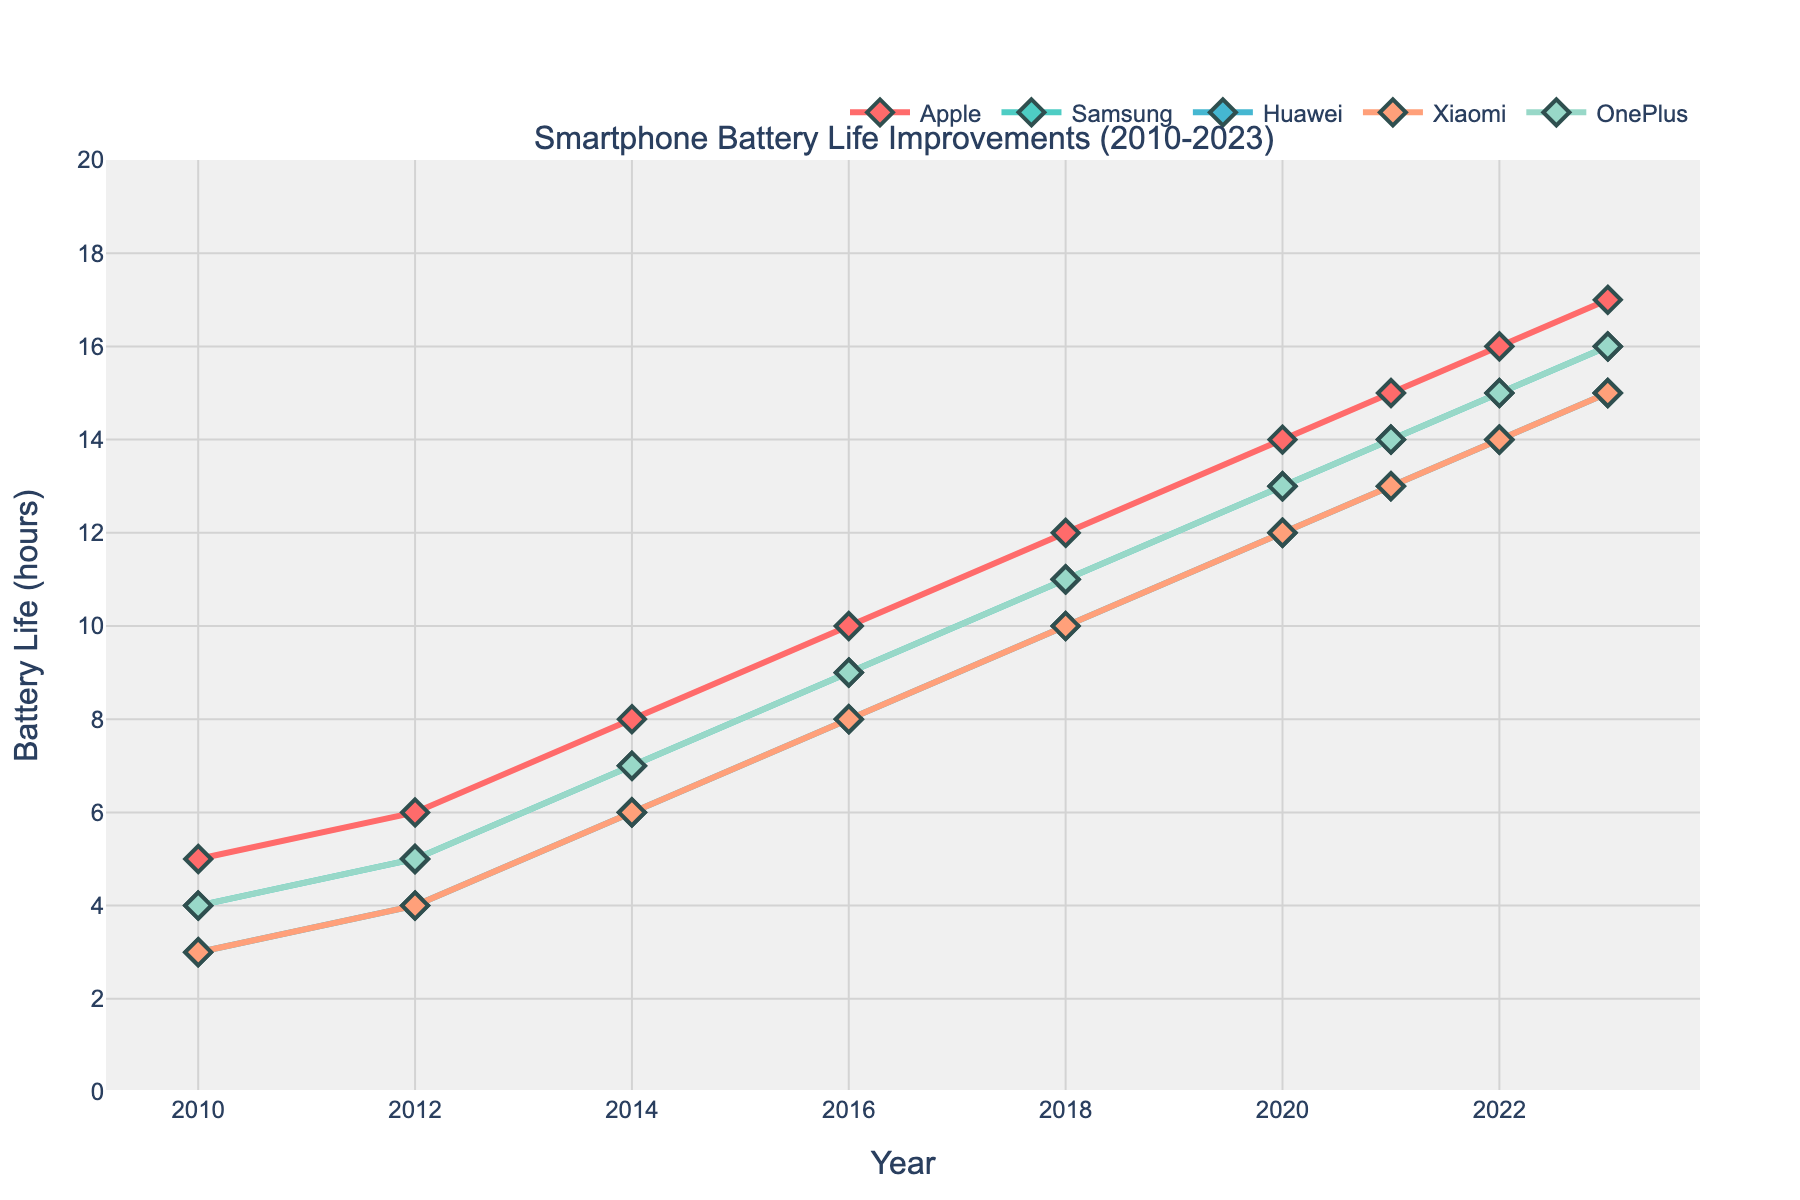What is the highest battery life recorded by Apple in the given period? To find the highest battery life reported by Apple, look at the line for Apple (colored in red) and find the maximum y-value from 2010 to 2023. The highest value is 17 hours in 2023.
Answer: 17 hours Between which years did Samsung see the greatest increase in battery life? To determine the period of greatest increase in battery life for Samsung, compare the vertical distances (change in y-values) between consecutive years. The largest increase is evident between 2010 and 2012, where the battery life went from 4 to 5 hours.
Answer: 2010-2012 At what year do all manufacturers first surpass 10 hours of battery life? Look at each manufacturer's line and determine the first year all surpass the 10-hour mark. In 2018, every manufacturer shows a battery life greater than 10 hours.
Answer: 2018 Which manufacturer had the slowest growth in battery life from 2010 to 2023? Calculate the increase in battery life for each manufacturer from 2010 to 2023. Apple increased from 5 to 17 hours, Samsung from 4 to 16 hours, Huawei from 3 to 15 hours, Xiaomi from 3 to 15 hours, and OnePlus from 4 to 16 hours. Huawei and Xiaomi both had the smallest increase of 12 hours.
Answer: Huawei and Xiaomi What is the average battery life improvement across all manufacturers in 2016? To find the average battery life improvement in 2016, sum up each manufacturer's battery life and divide by the number of manufacturers. (10 + 9 + 8 + 8 + 9)/5 = 44/5 = 8.8 hours.
Answer: 8.8 hours Which manufacturer had the most consistent growth in battery life over the years? Consistent growth can be interpreted as having a steady increase in y-values with little variation year-over-year. Inspect the visual representation of each line for smoothness. Apple shows a consistent linear growth from 2010 to 2023.
Answer: Apple How much did OnePlus's battery life grow from 2012 to 2020? To find the growth, subtract the 2012 value from the 2020 value for OnePlus. The battery life grew from 5 hours in 2012 to 13 hours in 2020. The growth is 13 - 5 = 8 hours.
Answer: 8 hours Which two manufacturers had equal battery life in any given year, and what was the battery life? Look for intersections or overlapping points on the chart for battery life values. In several years, Xiaomi and Huawei both have the same battery life. For instance, in 2018, both had 10 hours.
Answer: Xiaomi and Huawei, 10 hours in 2018 In what year did Huawei's battery life surpass 12 hours? Track Huawei's data values over the years. In 2020, Huawei's battery life went from below to above 12 hours.
Answer: 2020 